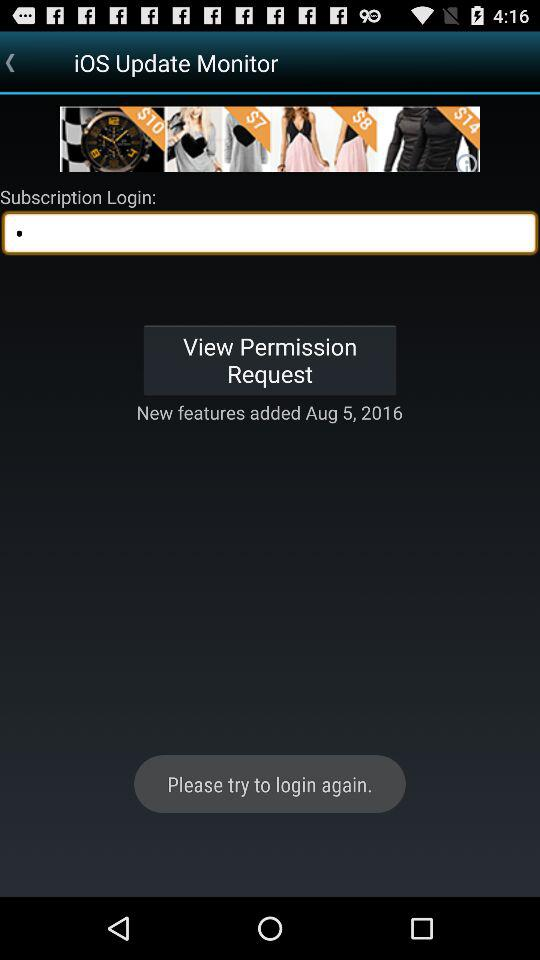What is the name of the application? The name of the application is "iOS Update Monitor". 